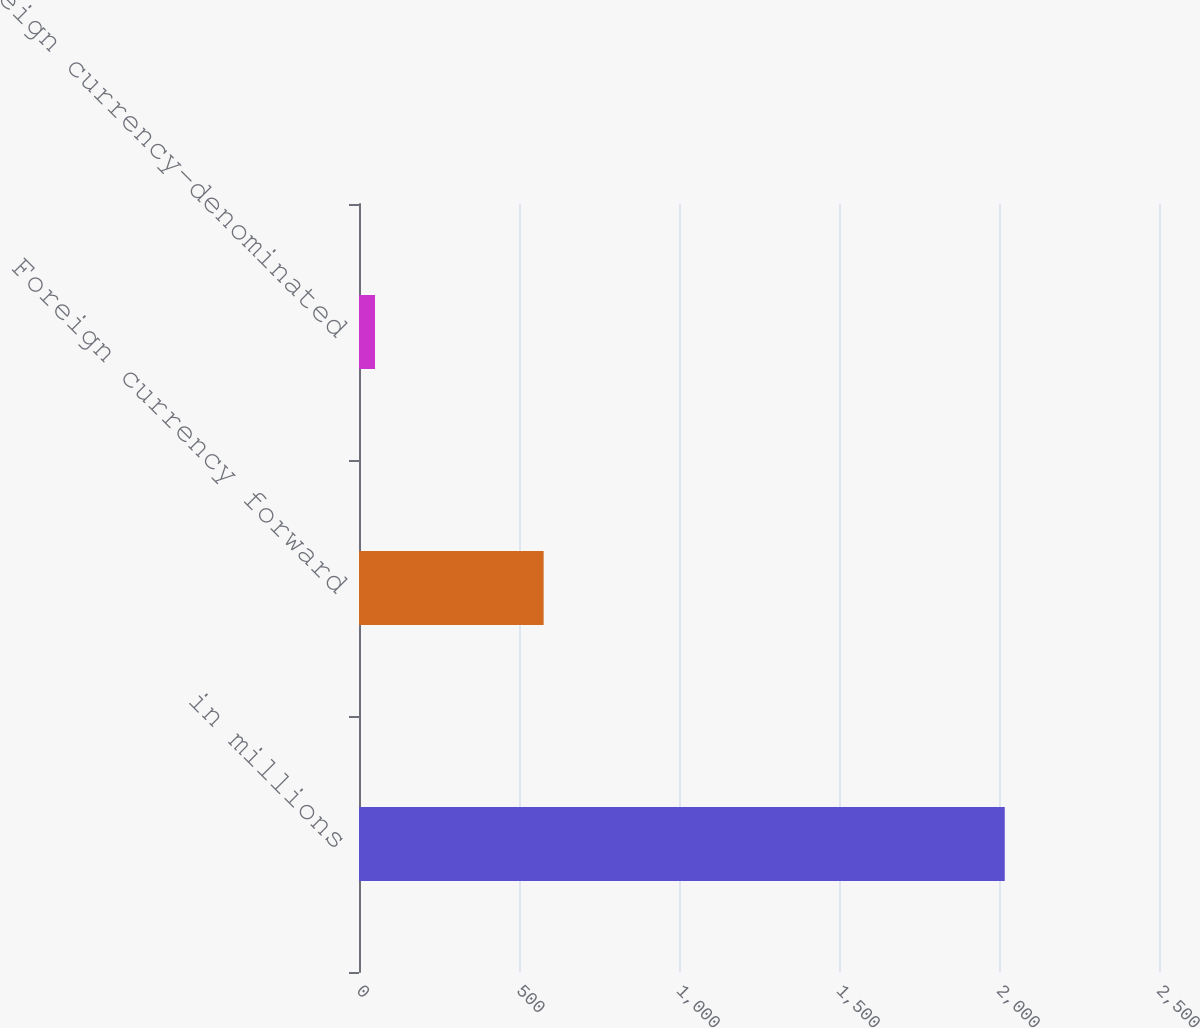Convert chart to OTSL. <chart><loc_0><loc_0><loc_500><loc_500><bar_chart><fcel>in millions<fcel>Foreign currency forward<fcel>Foreign currency-denominated<nl><fcel>2018<fcel>577<fcel>50<nl></chart> 